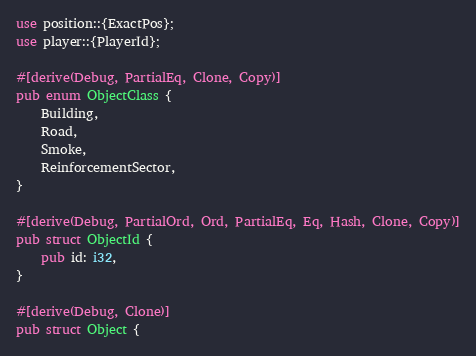Convert code to text. <code><loc_0><loc_0><loc_500><loc_500><_Rust_>use position::{ExactPos};
use player::{PlayerId};

#[derive(Debug, PartialEq, Clone, Copy)]
pub enum ObjectClass {
    Building,
    Road,
    Smoke,
    ReinforcementSector,
}

#[derive(Debug, PartialOrd, Ord, PartialEq, Eq, Hash, Clone, Copy)]
pub struct ObjectId {
    pub id: i32,
}

#[derive(Debug, Clone)]
pub struct Object {</code> 